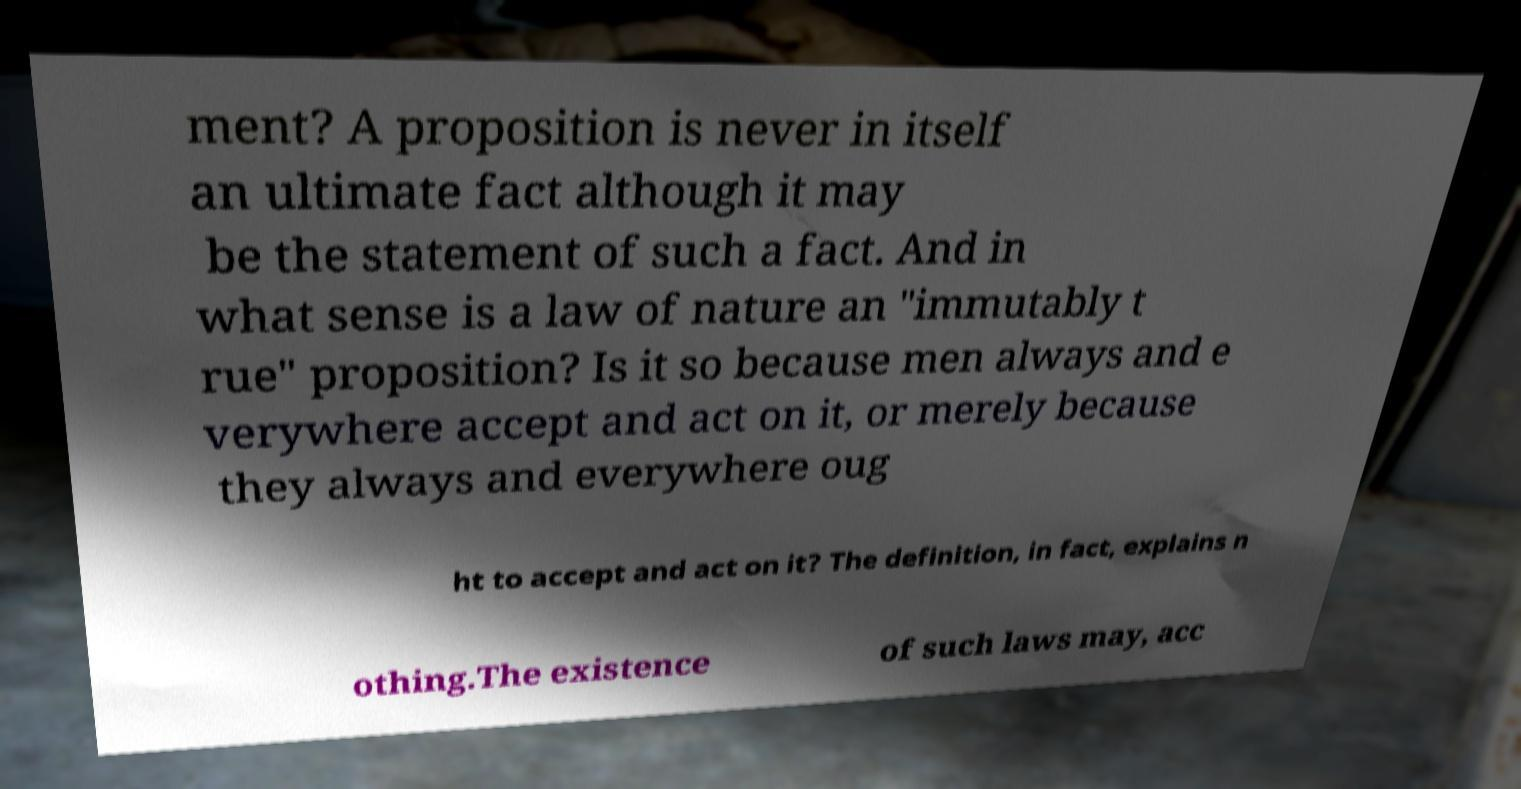Can you read and provide the text displayed in the image?This photo seems to have some interesting text. Can you extract and type it out for me? ment? A proposition is never in itself an ultimate fact although it may be the statement of such a fact. And in what sense is a law of nature an "immutably t rue" proposition? Is it so because men always and e verywhere accept and act on it, or merely because they always and everywhere oug ht to accept and act on it? The definition, in fact, explains n othing.The existence of such laws may, acc 